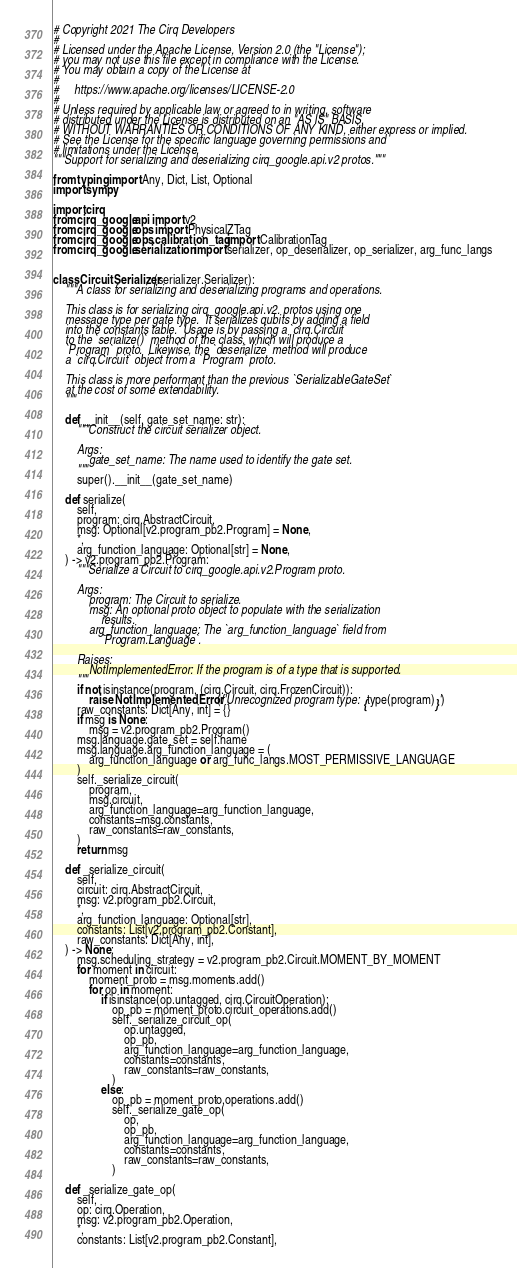Convert code to text. <code><loc_0><loc_0><loc_500><loc_500><_Python_># Copyright 2021 The Cirq Developers
#
# Licensed under the Apache License, Version 2.0 (the "License");
# you may not use this file except in compliance with the License.
# You may obtain a copy of the License at
#
#     https://www.apache.org/licenses/LICENSE-2.0
#
# Unless required by applicable law or agreed to in writing, software
# distributed under the License is distributed on an "AS IS" BASIS,
# WITHOUT WARRANTIES OR CONDITIONS OF ANY KIND, either express or implied.
# See the License for the specific language governing permissions and
# limitations under the License.
"""Support for serializing and deserializing cirq_google.api.v2 protos."""

from typing import Any, Dict, List, Optional
import sympy

import cirq
from cirq_google.api import v2
from cirq_google.ops import PhysicalZTag
from cirq_google.ops.calibration_tag import CalibrationTag
from cirq_google.serialization import serializer, op_deserializer, op_serializer, arg_func_langs


class CircuitSerializer(serializer.Serializer):
    """A class for serializing and deserializing programs and operations.

    This class is for serializing cirq_google.api.v2. protos using one
    message type per gate type.  It serializes qubits by adding a field
    into the constants table.  Usage is by passing a `cirq.Circuit`
    to the `serialize()` method of the class, which will produce a
    `Program` proto.  Likewise, the `deserialize` method will produce
    a `cirq.Circuit` object from a `Program` proto.

    This class is more performant than the previous `SerializableGateSet`
    at the cost of some extendability.
    """

    def __init__(self, gate_set_name: str):
        """Construct the circuit serializer object.

        Args:
            gate_set_name: The name used to identify the gate set.
        """
        super().__init__(gate_set_name)

    def serialize(
        self,
        program: cirq.AbstractCircuit,
        msg: Optional[v2.program_pb2.Program] = None,
        *,
        arg_function_language: Optional[str] = None,
    ) -> v2.program_pb2.Program:
        """Serialize a Circuit to cirq_google.api.v2.Program proto.

        Args:
            program: The Circuit to serialize.
            msg: An optional proto object to populate with the serialization
                results.
            arg_function_language: The `arg_function_language` field from
                `Program.Language`.

        Raises:
            NotImplementedError: If the program is of a type that is supported.
        """
        if not isinstance(program, (cirq.Circuit, cirq.FrozenCircuit)):
            raise NotImplementedError(f'Unrecognized program type: {type(program)}')
        raw_constants: Dict[Any, int] = {}
        if msg is None:
            msg = v2.program_pb2.Program()
        msg.language.gate_set = self.name
        msg.language.arg_function_language = (
            arg_function_language or arg_func_langs.MOST_PERMISSIVE_LANGUAGE
        )
        self._serialize_circuit(
            program,
            msg.circuit,
            arg_function_language=arg_function_language,
            constants=msg.constants,
            raw_constants=raw_constants,
        )
        return msg

    def _serialize_circuit(
        self,
        circuit: cirq.AbstractCircuit,
        msg: v2.program_pb2.Circuit,
        *,
        arg_function_language: Optional[str],
        constants: List[v2.program_pb2.Constant],
        raw_constants: Dict[Any, int],
    ) -> None:
        msg.scheduling_strategy = v2.program_pb2.Circuit.MOMENT_BY_MOMENT
        for moment in circuit:
            moment_proto = msg.moments.add()
            for op in moment:
                if isinstance(op.untagged, cirq.CircuitOperation):
                    op_pb = moment_proto.circuit_operations.add()
                    self._serialize_circuit_op(
                        op.untagged,
                        op_pb,
                        arg_function_language=arg_function_language,
                        constants=constants,
                        raw_constants=raw_constants,
                    )
                else:
                    op_pb = moment_proto.operations.add()
                    self._serialize_gate_op(
                        op,
                        op_pb,
                        arg_function_language=arg_function_language,
                        constants=constants,
                        raw_constants=raw_constants,
                    )

    def _serialize_gate_op(
        self,
        op: cirq.Operation,
        msg: v2.program_pb2.Operation,
        *,
        constants: List[v2.program_pb2.Constant],</code> 